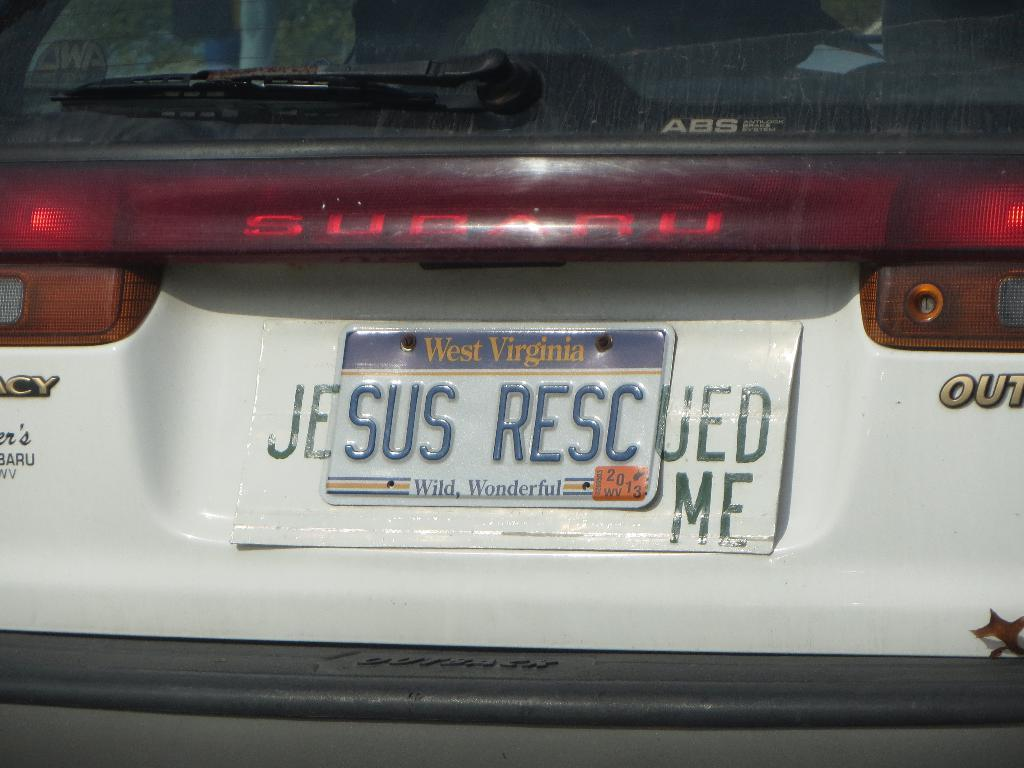<image>
Present a compact description of the photo's key features. Car owner gets creative by adding Je and UED ME to their SUS RESC licence plate 